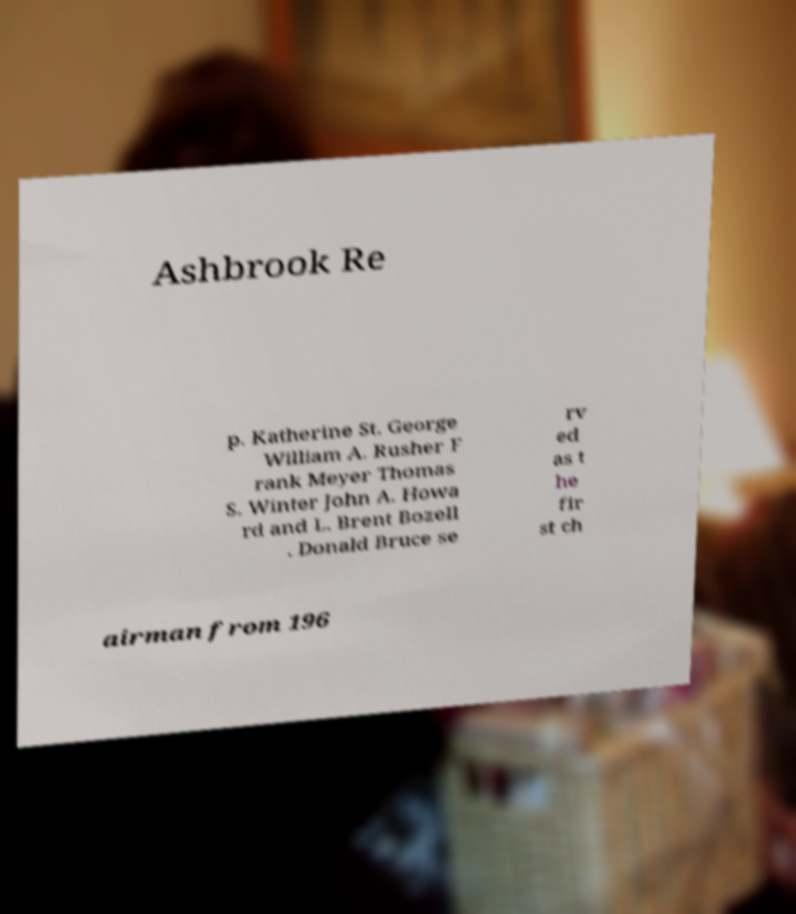What messages or text are displayed in this image? I need them in a readable, typed format. Ashbrook Re p. Katherine St. George William A. Rusher F rank Meyer Thomas S. Winter John A. Howa rd and L. Brent Bozell . Donald Bruce se rv ed as t he fir st ch airman from 196 